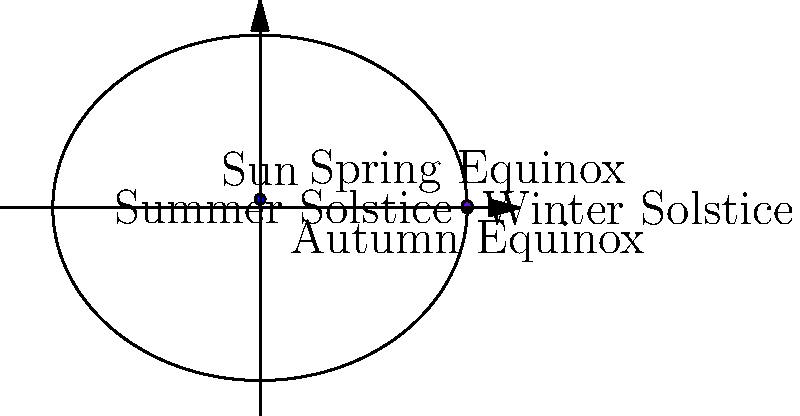In the context of native plant restoration projects, how does the Earth's elliptical orbit, as shown in the diagram, influence seasonal changes in plant habitats? Specifically, consider the implications for plant growth cycles and restoration timing at different points in the orbit. 1. Earth's elliptical orbit:
   - The diagram shows Earth's orbit around the Sun is elliptical, not perfectly circular.
   - The Sun is slightly off-center, creating varying distances between Earth and Sun throughout the year.

2. Seasonal changes:
   - The orbit is divided into four key points: Winter Solstice, Spring Equinox, Summer Solstice, and Autumn Equinox.
   - These points correspond to the changing seasons on Earth.

3. Distance variation:
   - At perihelion (closest to Sun, near Winter Solstice), Earth receives more solar radiation.
   - At aphelion (farthest from Sun, near Summer Solstice), Earth receives less solar radiation.

4. Impact on plant habitats:
   - Varying solar radiation affects temperature and day length in different seasons.
   - These changes trigger physiological responses in native plants, such as dormancy, flowering, and seed production.

5. Plant growth cycles:
   - Winter Solstice: Many plants are dormant due to cold temperatures and shorter days.
   - Spring Equinox: Increasing daylight and warmth triggers growth and flowering in many species.
   - Summer Solstice: Peak growing season for many plants, despite being furthest from Sun.
   - Autumn Equinox: Decreasing daylight signals plants to prepare for dormancy.

6. Restoration timing:
   - Planting should align with natural growth cycles of native species.
   - Spring planting often coincides with natural germination periods.
   - Fall planting can allow roots to establish before winter dormancy.

7. Considerations for land managers:
   - Timing of restoration activities should consider these orbital-induced seasonal changes.
   - Different plant species may have varied responses to these seasonal cues.
   - Local climate and microhabitats may modify the effects of Earth's orbital position.
Answer: Earth's elliptical orbit causes seasonal variations in solar radiation, influencing plant growth cycles and optimal restoration timing. 